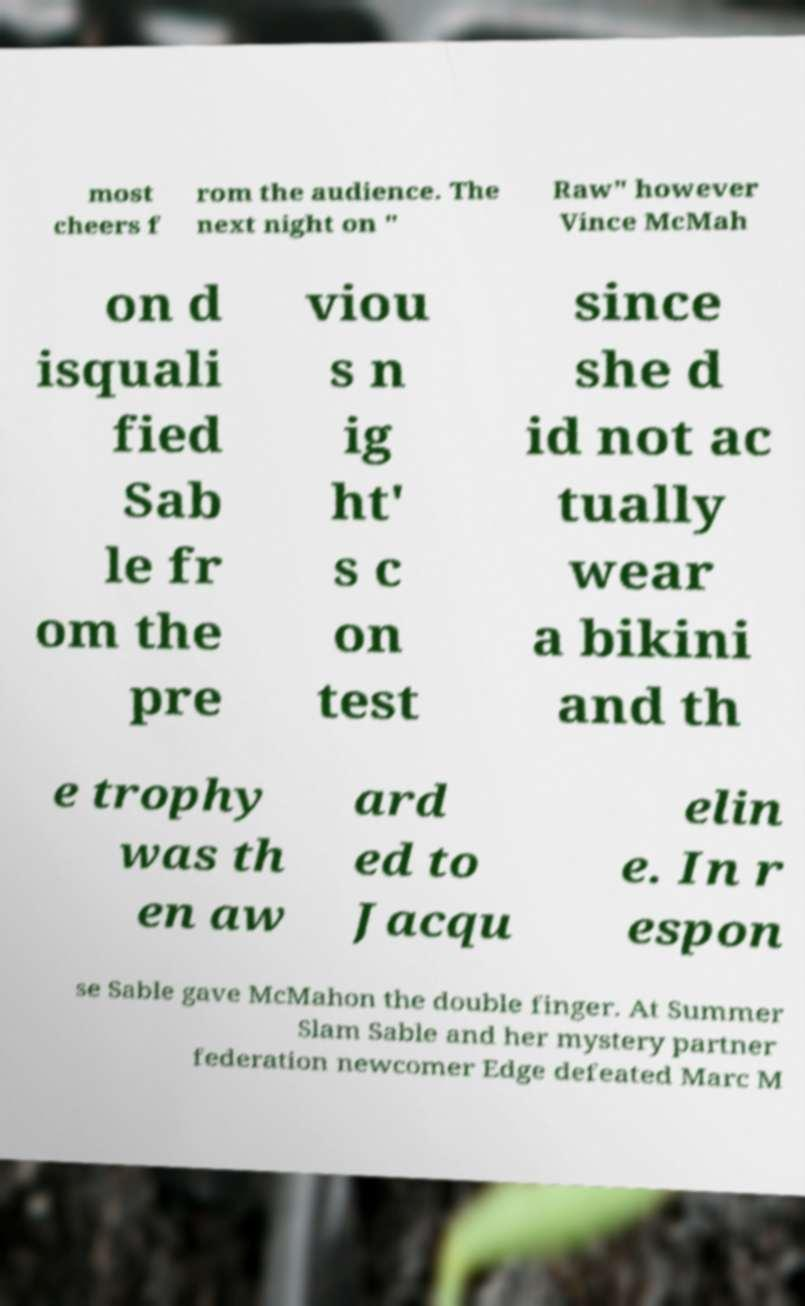Can you accurately transcribe the text from the provided image for me? most cheers f rom the audience. The next night on " Raw" however Vince McMah on d isquali fied Sab le fr om the pre viou s n ig ht' s c on test since she d id not ac tually wear a bikini and th e trophy was th en aw ard ed to Jacqu elin e. In r espon se Sable gave McMahon the double finger. At Summer Slam Sable and her mystery partner federation newcomer Edge defeated Marc M 